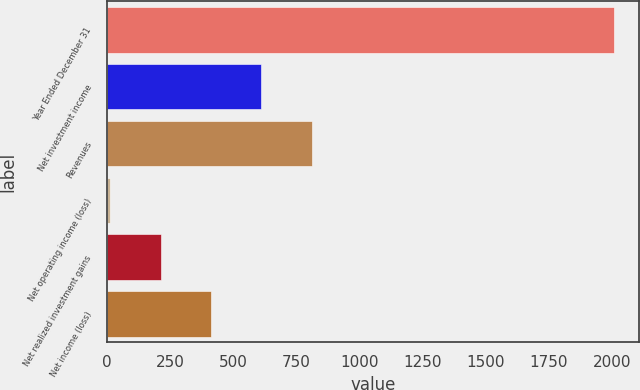<chart> <loc_0><loc_0><loc_500><loc_500><bar_chart><fcel>Year Ended December 31<fcel>Net investment income<fcel>Revenues<fcel>Net operating income (loss)<fcel>Net realized investment gains<fcel>Net income (loss)<nl><fcel>2006<fcel>611.6<fcel>810.8<fcel>14<fcel>213.2<fcel>412.4<nl></chart> 